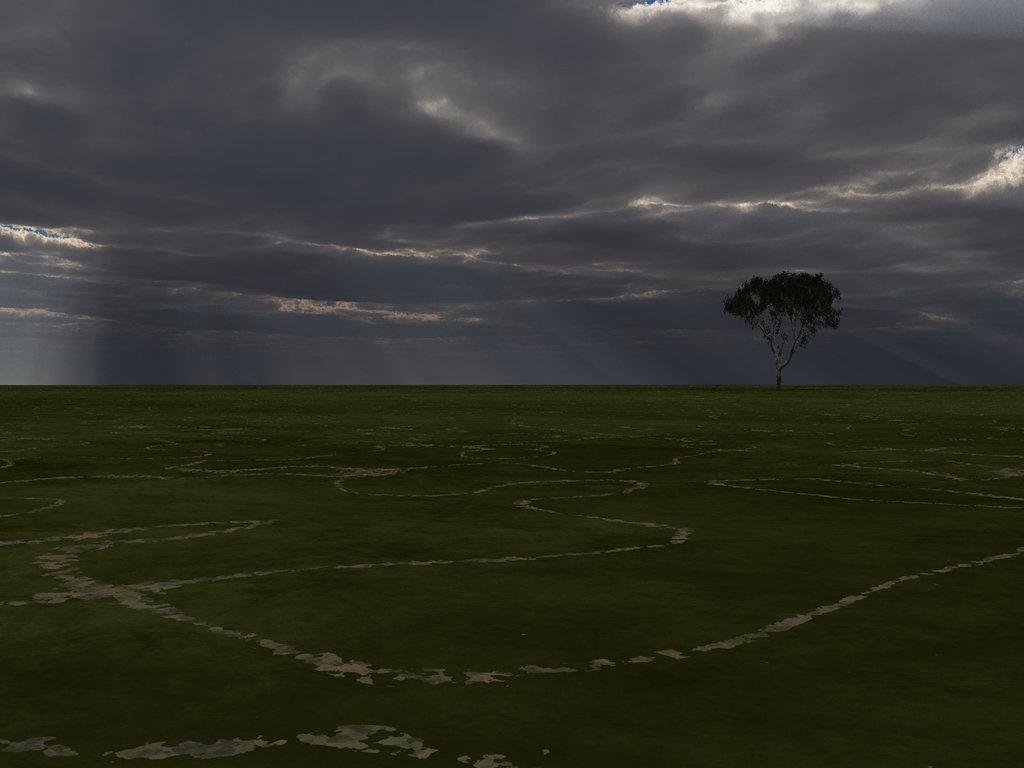What type of plant can be seen in the picture? There is a tree in the picture. What is covering the ground in the picture? There is grass on the ground in the picture. How would you describe the sky in the picture? The sky is cloudy in the picture. What type of insurance policy is being discussed in the picture? There is no discussion of insurance policies in the picture; it features a tree, grass, and a cloudy sky. How many eyes can be seen in the picture? There are no eyes visible in the picture; it features a tree, grass, and a cloudy sky. 